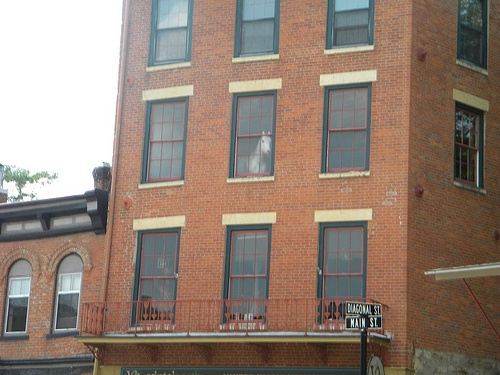Describe the objects in this image and their specific colors. I can see a horse in white, darkgray, gray, and lightgray tones in this image. 